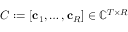<formula> <loc_0><loc_0><loc_500><loc_500>C \colon = [ c _ { 1 } , \dots , c _ { R } ] \in \mathbb { C } ^ { T \times R }</formula> 